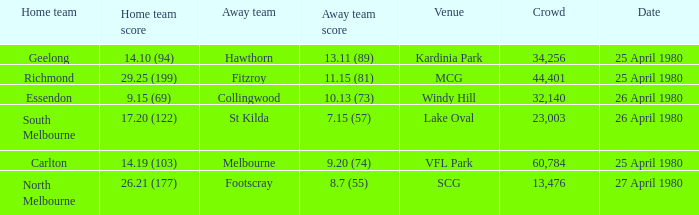On what date did the match at Lake Oval take place? 26 April 1980. 